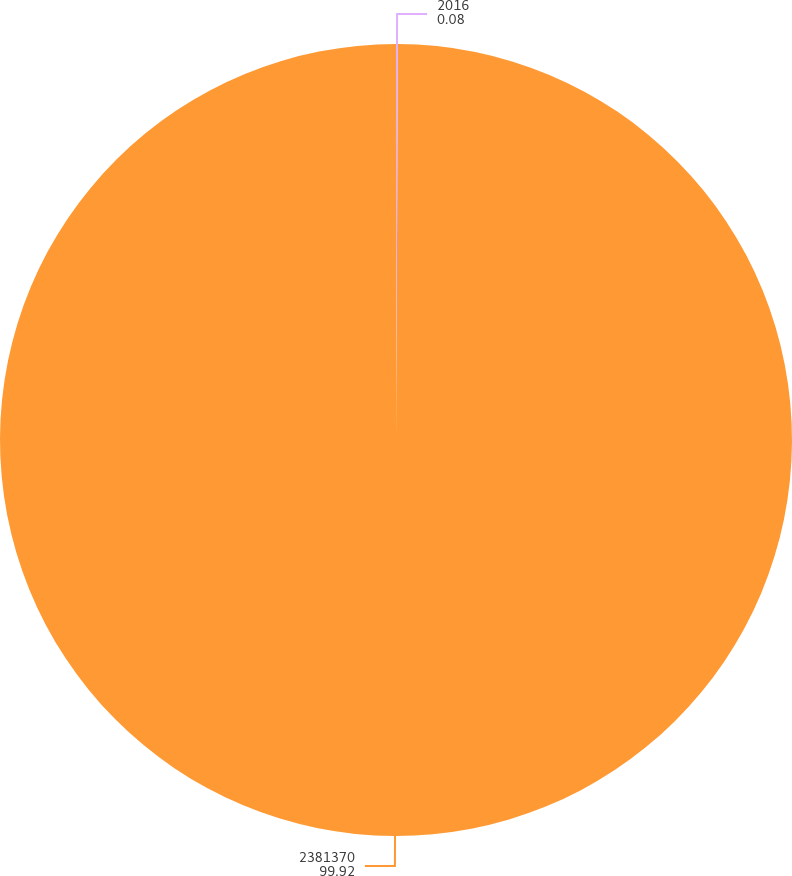<chart> <loc_0><loc_0><loc_500><loc_500><pie_chart><fcel>2016<fcel>2381370<nl><fcel>0.08%<fcel>99.92%<nl></chart> 